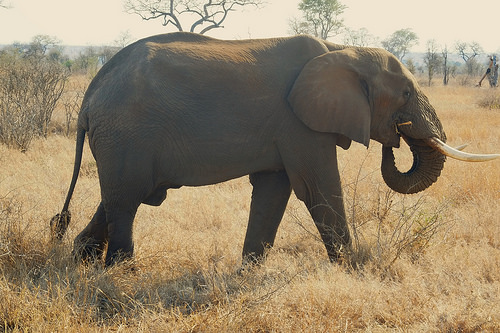<image>
Is there a tree behind the elephant? Yes. From this viewpoint, the tree is positioned behind the elephant, with the elephant partially or fully occluding the tree. Where is the elephant in relation to the tree? Is it behind the tree? No. The elephant is not behind the tree. From this viewpoint, the elephant appears to be positioned elsewhere in the scene. Where is the elephant in relation to the bush? Is it to the right of the bush? Yes. From this viewpoint, the elephant is positioned to the right side relative to the bush. Is there a tree above the elephant? No. The tree is not positioned above the elephant. The vertical arrangement shows a different relationship. 